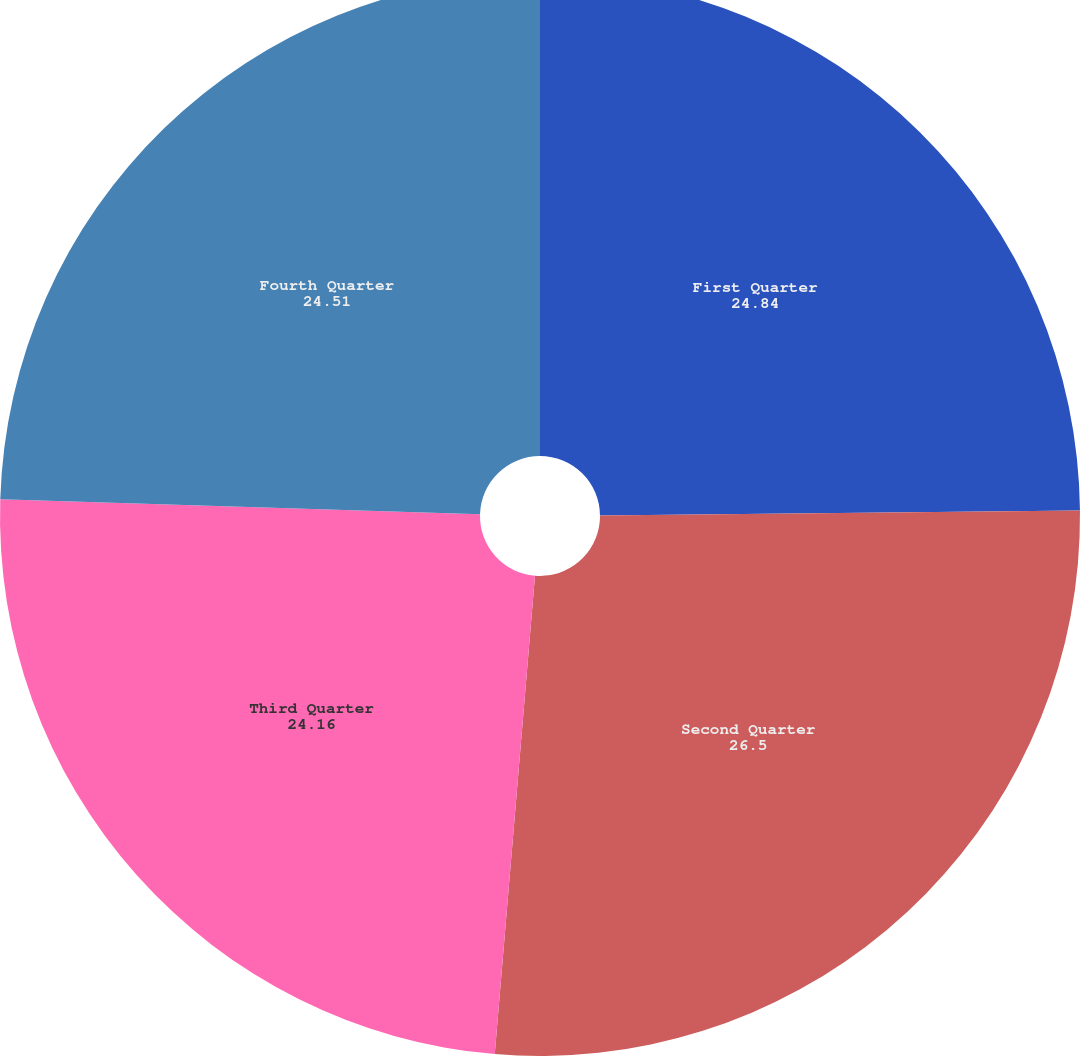Convert chart. <chart><loc_0><loc_0><loc_500><loc_500><pie_chart><fcel>First Quarter<fcel>Second Quarter<fcel>Third Quarter<fcel>Fourth Quarter<nl><fcel>24.84%<fcel>26.5%<fcel>24.16%<fcel>24.51%<nl></chart> 